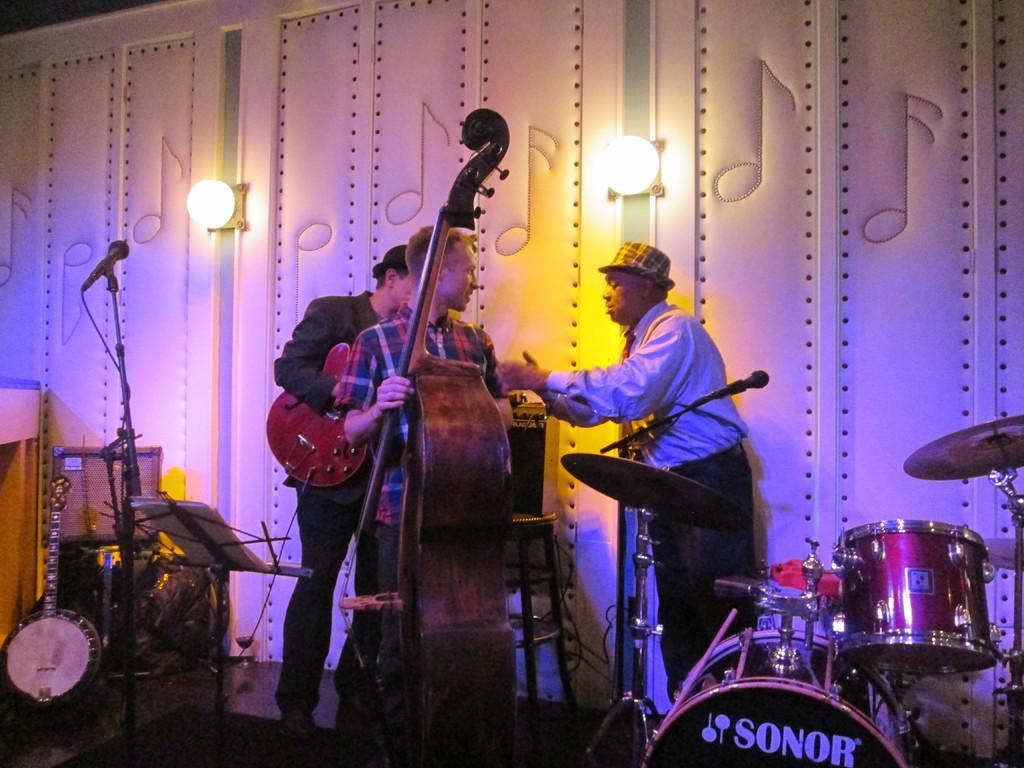How would you summarize this image in a sentence or two? In this Image I see 3 men in which 2 of them are holding the musical instruments and there are mice and other musical instruments over here. In the background I see 2 lights. 